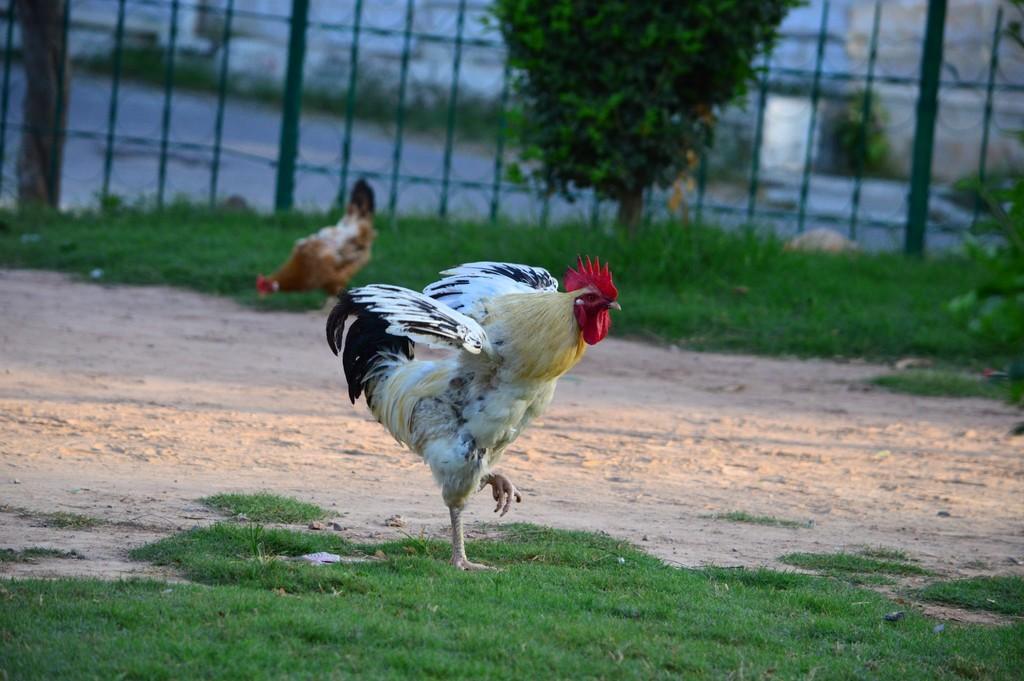Please provide a concise description of this image. As we can see in the image there is grass, fence, plant and hens. In the background there are buildings. 